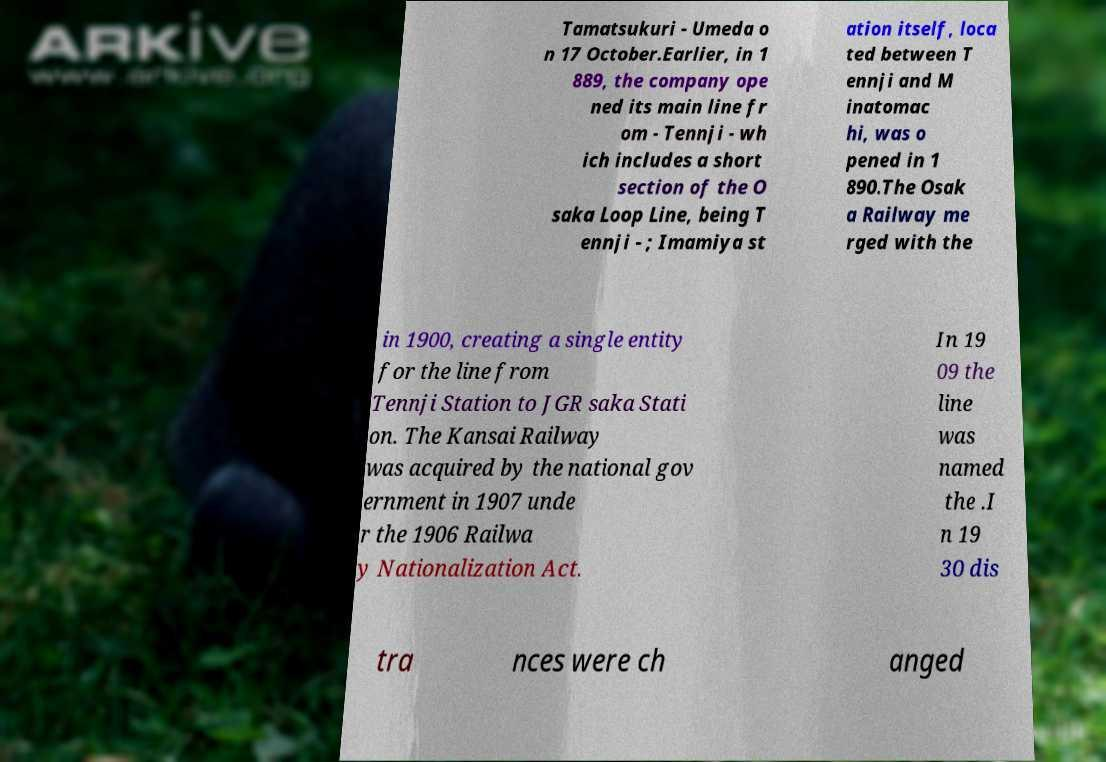Can you accurately transcribe the text from the provided image for me? Tamatsukuri - Umeda o n 17 October.Earlier, in 1 889, the company ope ned its main line fr om - Tennji - wh ich includes a short section of the O saka Loop Line, being T ennji - ; Imamiya st ation itself, loca ted between T ennji and M inatomac hi, was o pened in 1 890.The Osak a Railway me rged with the in 1900, creating a single entity for the line from Tennji Station to JGR saka Stati on. The Kansai Railway was acquired by the national gov ernment in 1907 unde r the 1906 Railwa y Nationalization Act. In 19 09 the line was named the .I n 19 30 dis tra nces were ch anged 